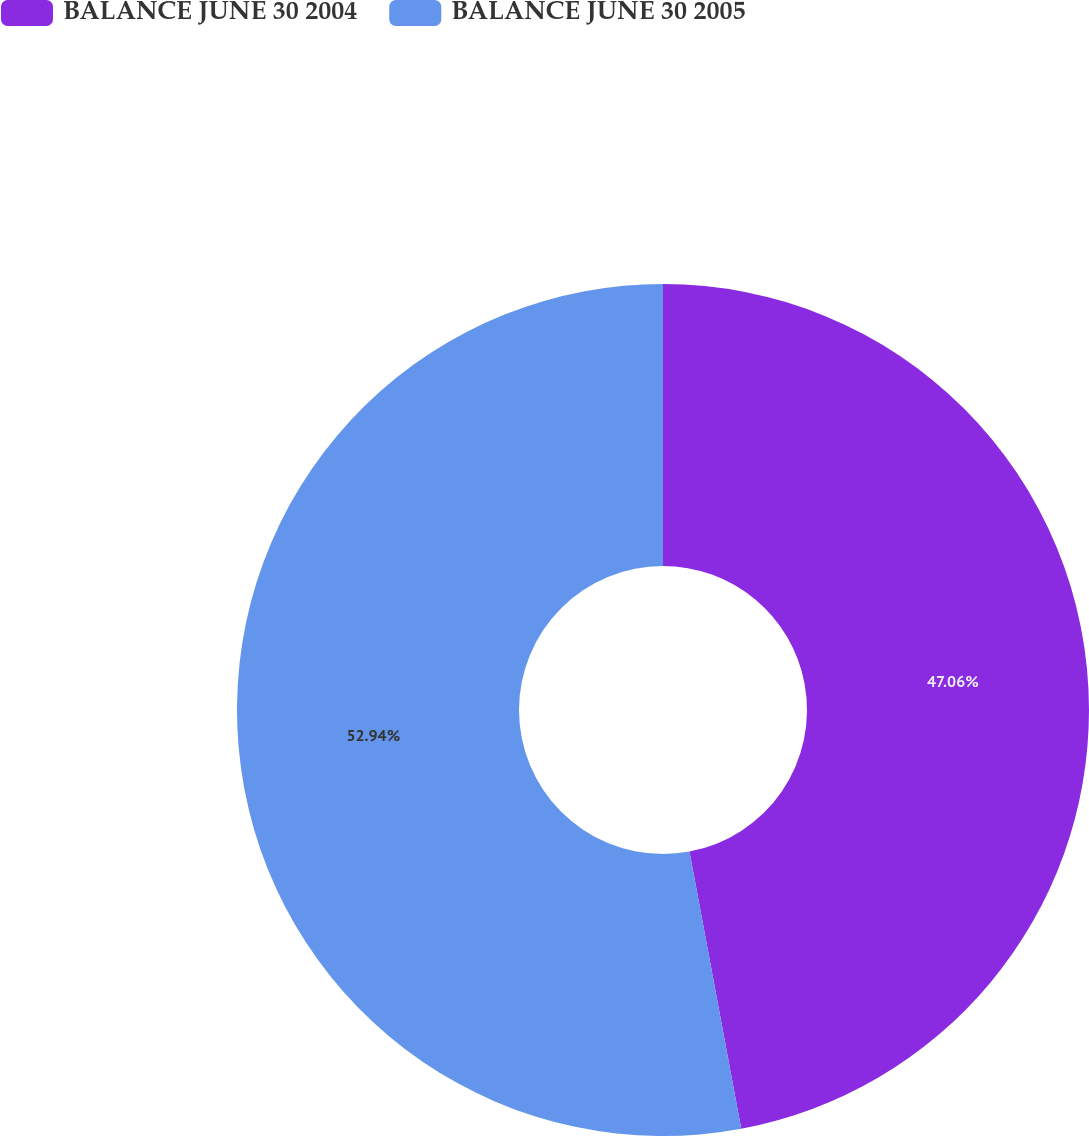Convert chart. <chart><loc_0><loc_0><loc_500><loc_500><pie_chart><fcel>BALANCE JUNE 30 2004<fcel>BALANCE JUNE 30 2005<nl><fcel>47.06%<fcel>52.94%<nl></chart> 